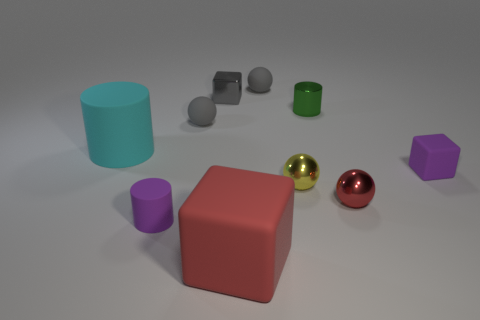Subtract all spheres. How many objects are left? 6 Subtract all gray rubber cylinders. Subtract all tiny rubber objects. How many objects are left? 6 Add 1 tiny things. How many tiny things are left? 9 Add 10 large brown cylinders. How many large brown cylinders exist? 10 Subtract 0 green balls. How many objects are left? 10 